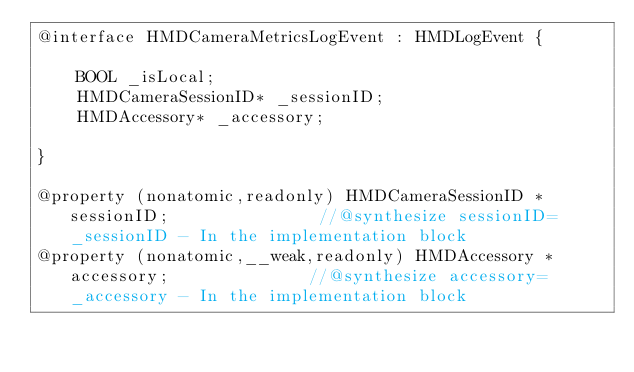Convert code to text. <code><loc_0><loc_0><loc_500><loc_500><_C_>@interface HMDCameraMetricsLogEvent : HMDLogEvent {

	BOOL _isLocal;
	HMDCameraSessionID* _sessionID;
	HMDAccessory* _accessory;

}

@property (nonatomic,readonly) HMDCameraSessionID * sessionID;               //@synthesize sessionID=_sessionID - In the implementation block
@property (nonatomic,__weak,readonly) HMDAccessory * accessory;              //@synthesize accessory=_accessory - In the implementation block</code> 